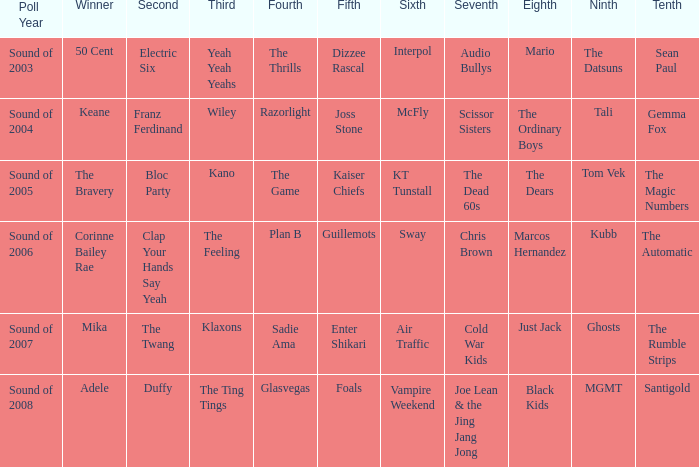When Kubb is in 9th, who is in 10th? The Automatic. Parse the full table. {'header': ['Poll Year', 'Winner', 'Second', 'Third', 'Fourth', 'Fifth', 'Sixth', 'Seventh', 'Eighth', 'Ninth', 'Tenth'], 'rows': [['Sound of 2003', '50 Cent', 'Electric Six', 'Yeah Yeah Yeahs', 'The Thrills', 'Dizzee Rascal', 'Interpol', 'Audio Bullys', 'Mario', 'The Datsuns', 'Sean Paul'], ['Sound of 2004', 'Keane', 'Franz Ferdinand', 'Wiley', 'Razorlight', 'Joss Stone', 'McFly', 'Scissor Sisters', 'The Ordinary Boys', 'Tali', 'Gemma Fox'], ['Sound of 2005', 'The Bravery', 'Bloc Party', 'Kano', 'The Game', 'Kaiser Chiefs', 'KT Tunstall', 'The Dead 60s', 'The Dears', 'Tom Vek', 'The Magic Numbers'], ['Sound of 2006', 'Corinne Bailey Rae', 'Clap Your Hands Say Yeah', 'The Feeling', 'Plan B', 'Guillemots', 'Sway', 'Chris Brown', 'Marcos Hernandez', 'Kubb', 'The Automatic'], ['Sound of 2007', 'Mika', 'The Twang', 'Klaxons', 'Sadie Ama', 'Enter Shikari', 'Air Traffic', 'Cold War Kids', 'Just Jack', 'Ghosts', 'The Rumble Strips'], ['Sound of 2008', 'Adele', 'Duffy', 'The Ting Tings', 'Glasvegas', 'Foals', 'Vampire Weekend', 'Joe Lean & the Jing Jang Jong', 'Black Kids', 'MGMT', 'Santigold']]} 